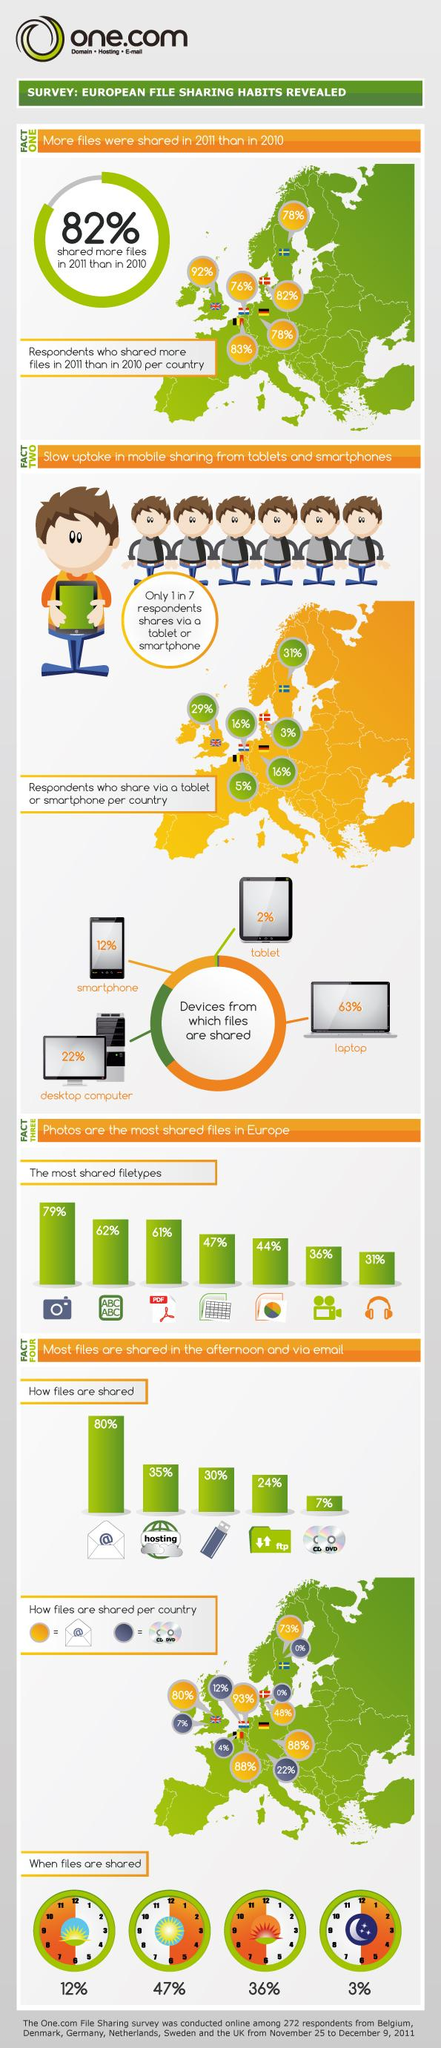Highlight a few significant elements in this photo. In a study, 98% of respondents reported sharing data using laptops, smartphones, and desktops. Eighty-six percent of respondents shared using devices other than tablets or smartphones. The time when files are most frequently shared is the afternoon. According to the provided information, 61% of PDF files are shared. Approximately 14% of respondents share data using tablets and smartphones combined. 